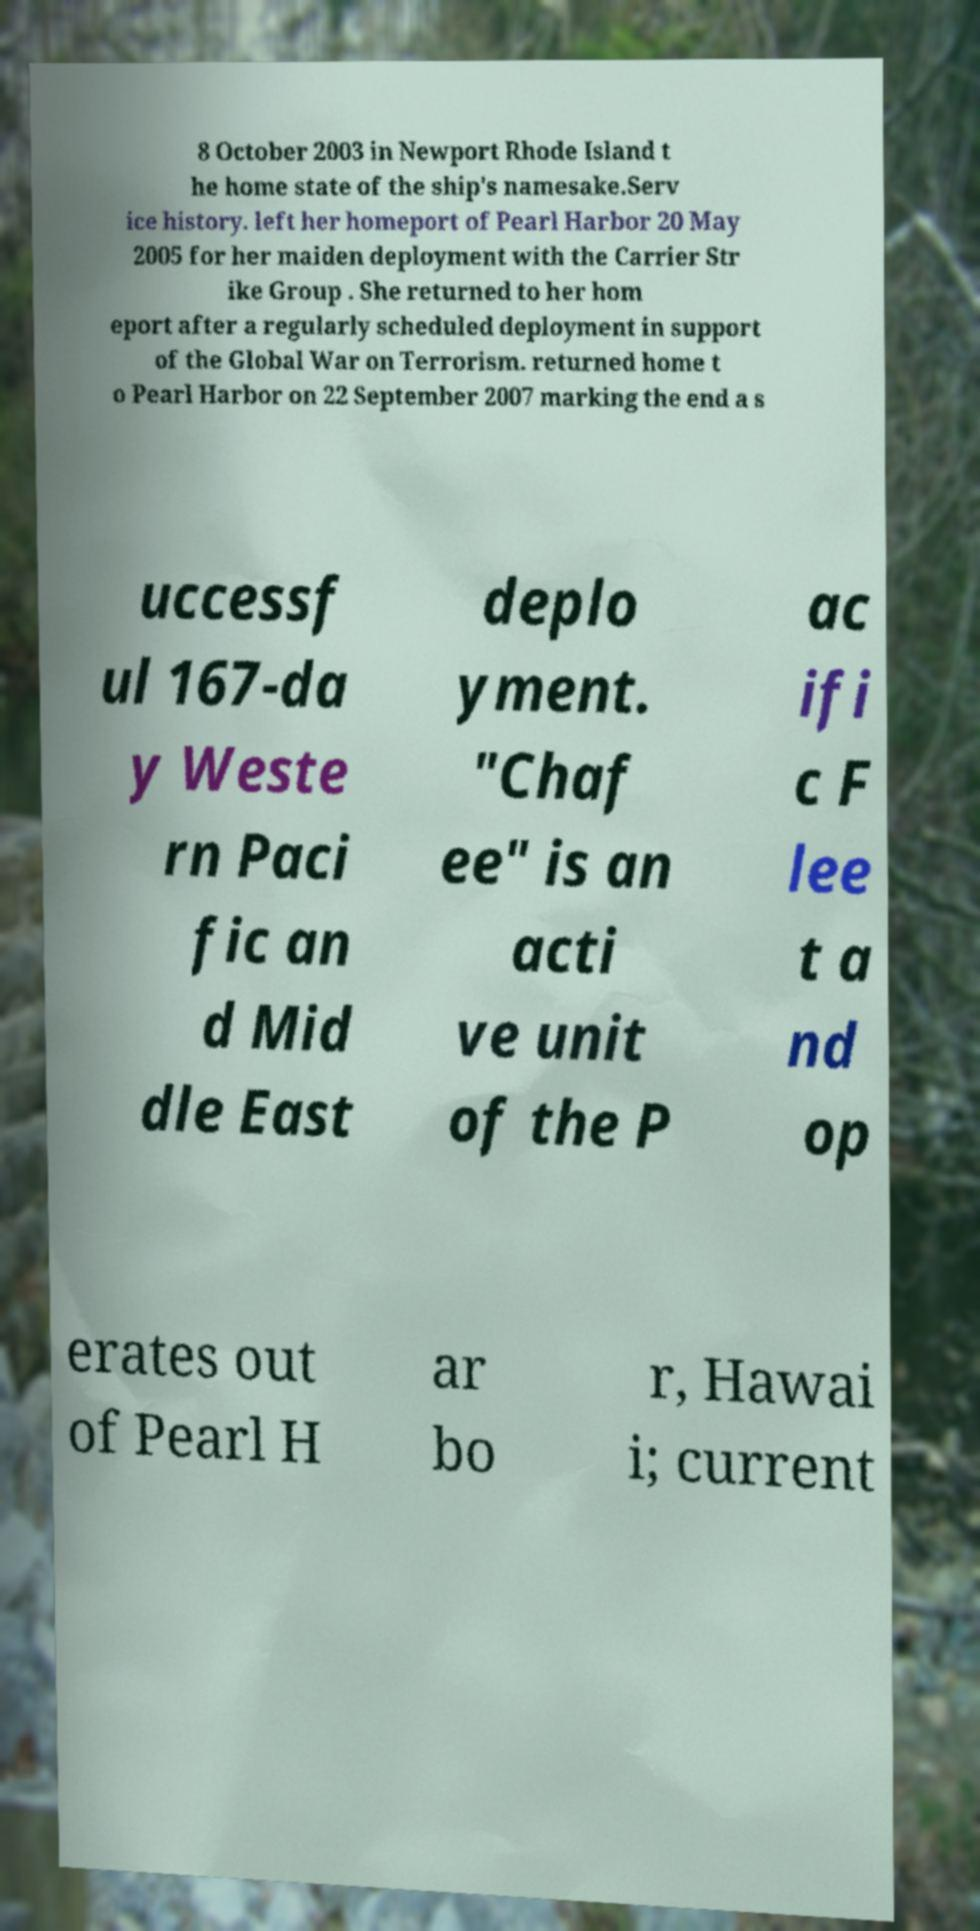Can you accurately transcribe the text from the provided image for me? 8 October 2003 in Newport Rhode Island t he home state of the ship's namesake.Serv ice history. left her homeport of Pearl Harbor 20 May 2005 for her maiden deployment with the Carrier Str ike Group . She returned to her hom eport after a regularly scheduled deployment in support of the Global War on Terrorism. returned home t o Pearl Harbor on 22 September 2007 marking the end a s uccessf ul 167-da y Weste rn Paci fic an d Mid dle East deplo yment. "Chaf ee" is an acti ve unit of the P ac ifi c F lee t a nd op erates out of Pearl H ar bo r, Hawai i; current 